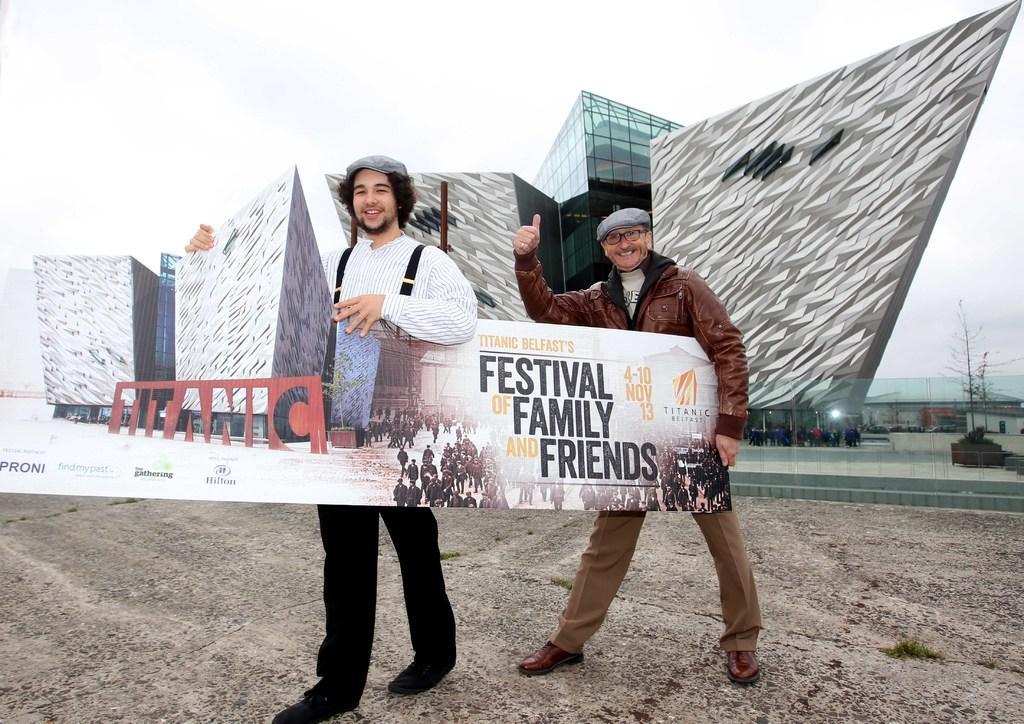In one or two sentences, can you explain what this image depicts? In the image there are two men,they are holding a board in the hand and both of them are smiling and behind the man there is a huge building. 